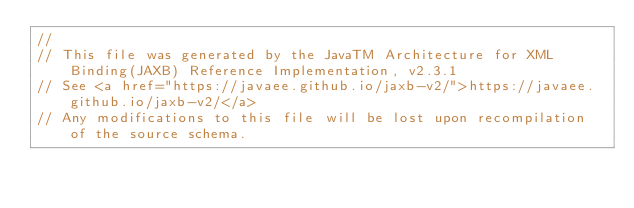Convert code to text. <code><loc_0><loc_0><loc_500><loc_500><_Java_>//
// This file was generated by the JavaTM Architecture for XML Binding(JAXB) Reference Implementation, v2.3.1 
// See <a href="https://javaee.github.io/jaxb-v2/">https://javaee.github.io/jaxb-v2/</a> 
// Any modifications to this file will be lost upon recompilation of the source schema. </code> 